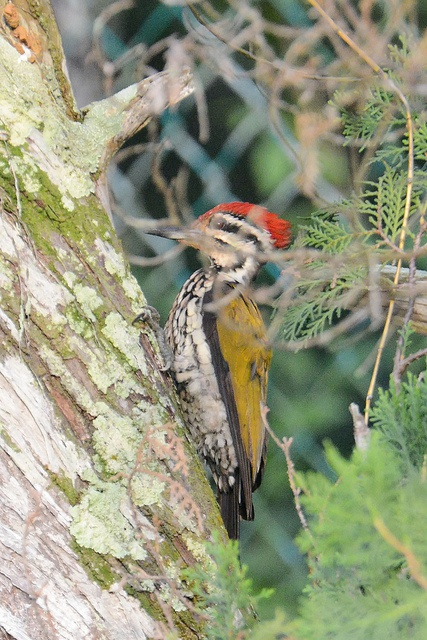Describe the objects in this image and their specific colors. I can see a bird in tan, darkgray, gray, and black tones in this image. 